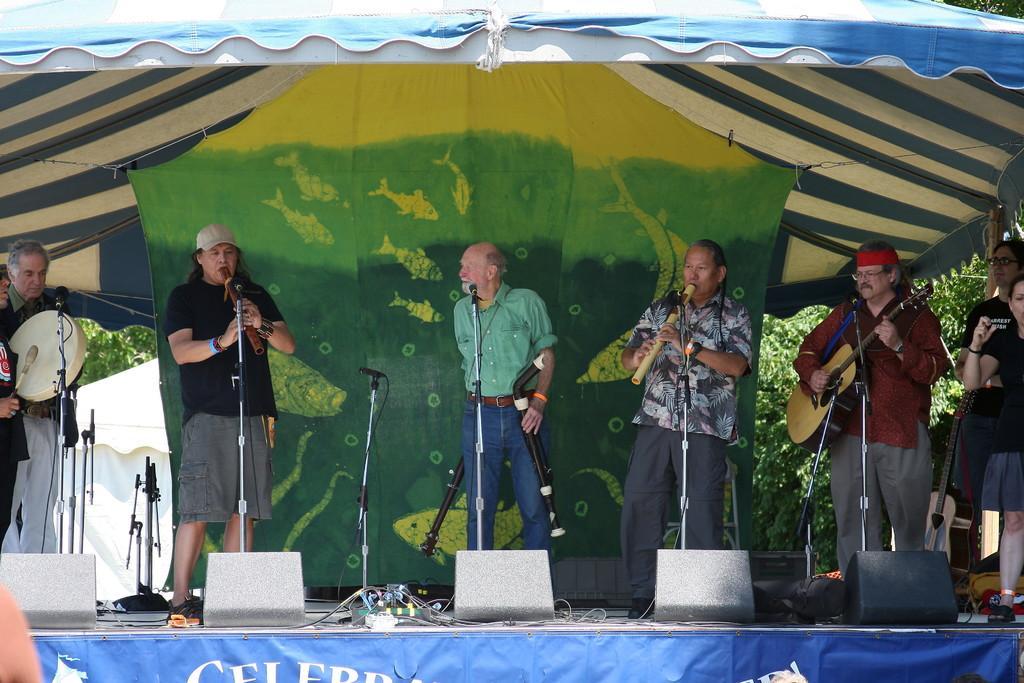Can you describe this image briefly? In this picture we can see a band performing on a stage, on the stage people, mics, cables and other objects. The people are playing various musical instruments. At the top it is looking like a tent. At the bottom there is a banner. 